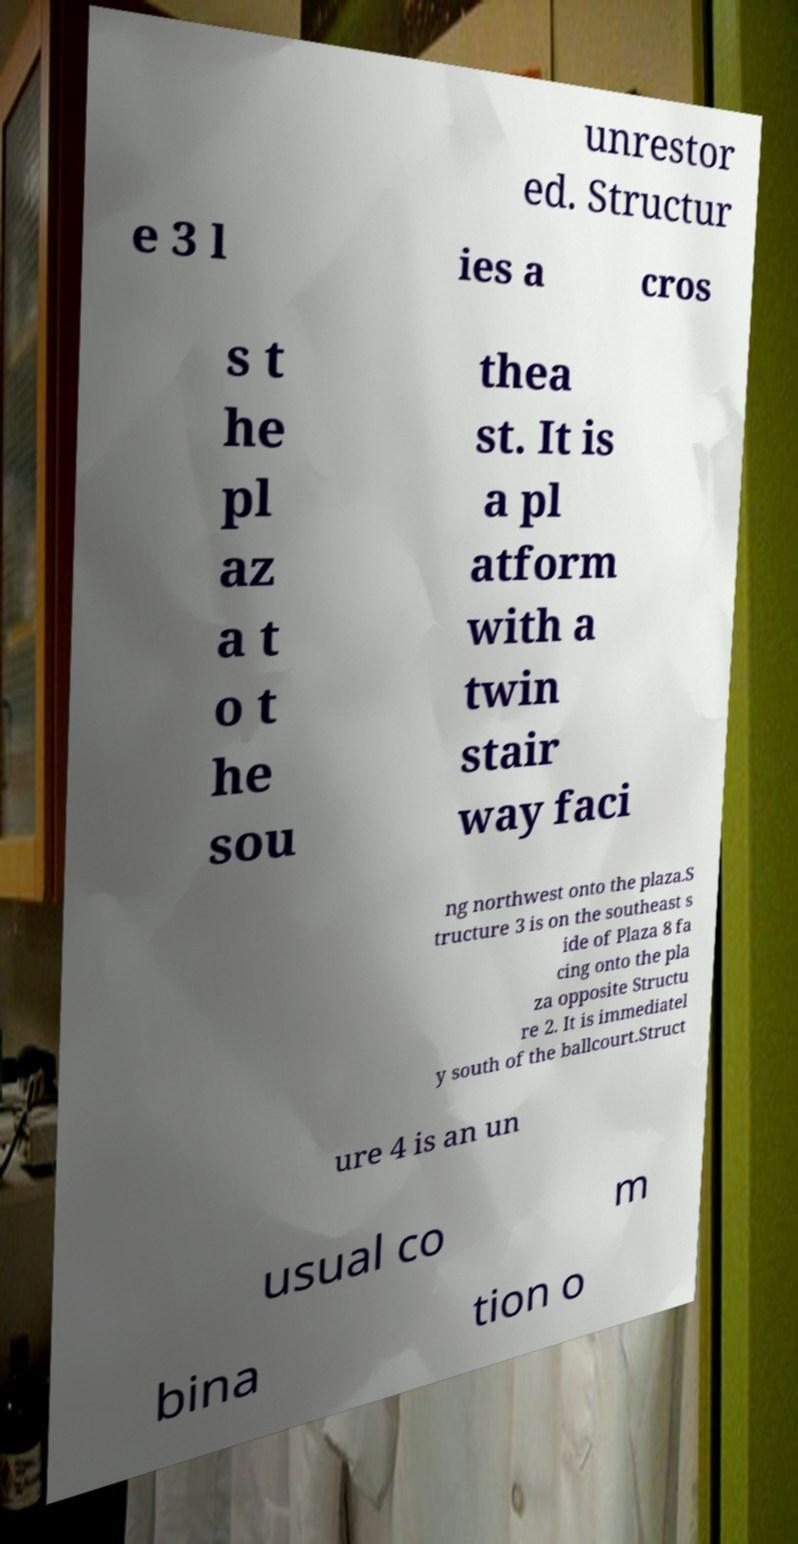Please read and relay the text visible in this image. What does it say? unrestor ed. Structur e 3 l ies a cros s t he pl az a t o t he sou thea st. It is a pl atform with a twin stair way faci ng northwest onto the plaza.S tructure 3 is on the southeast s ide of Plaza 8 fa cing onto the pla za opposite Structu re 2. It is immediatel y south of the ballcourt.Struct ure 4 is an un usual co m bina tion o 